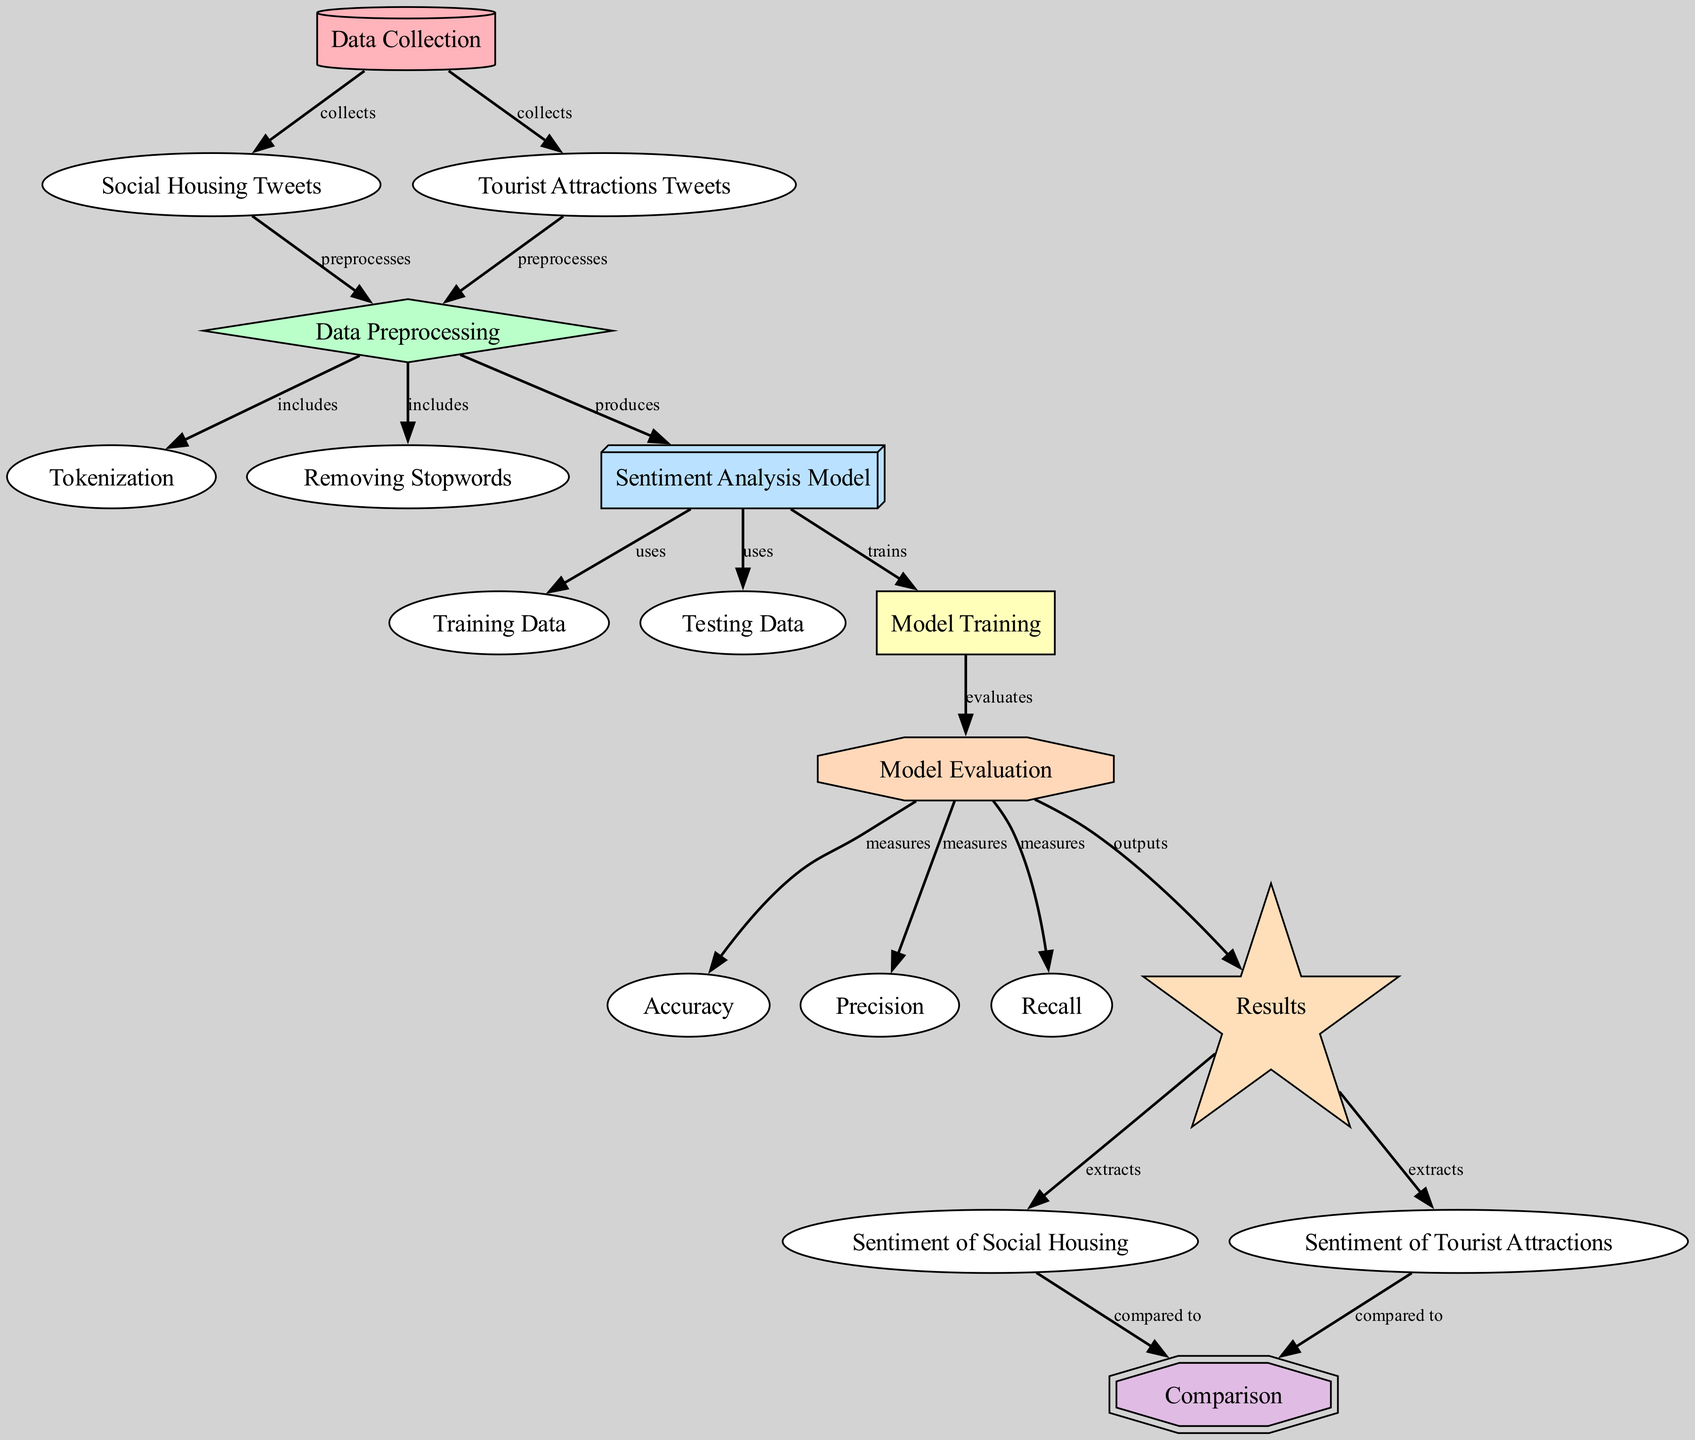What is the first step in the diagram? The diagram begins with the "Data Collection" node, which is the starting point for the entire process.
Answer: Data Collection How many types of tweets are collected? The diagram shows two types of tweets being collected: "Social Housing Tweets" and "Tourist Attractions Tweets." Therefore, the number is two.
Answer: Two Which node directly processes both types of tweets? The "Preprocessing" node directly processes both "Social Housing Tweets" and "Tourist Attractions Tweets," as indicated by the arrows leading to it from both nodes.
Answer: Preprocessing What is compared in the diagram? The diagram contains a "Comparison" node that compares the sentiments from "Sentiment of Social Housing" and "Sentiment of Tourist Attractions."
Answer: Sentiments List three metrics used in model evaluation. The diagram indicates that "Accuracy," "Precision," and "Recall" are measured as part of the model evaluation step.
Answer: Accuracy, Precision, Recall What does the "Sentiment Analysis Model" use for training? The "Sentiment Analysis Model" uses the "Training Data" node for training, as represented by the arrow pointing from "Training Data" to "Sentiment Analysis Model."
Answer: Training Data What kind of outputs does the "Model Evaluation" generate? The "Model Evaluation" node directly outputs the "Results," indicating that it produces these results after evaluating the model.
Answer: Results Which node is responsible for sentiment extraction? The "Results" node extracts sentiments for both social housing and tourist attractions, as shown by the arrows leading to "Sentiment of Social Housing" and "Sentiment of Tourist Attractions."
Answer: Results How many nodes are involved in the data preprocessing phase? There are three nodes involved in preprocessing: "Tokenization," "Removing Stopwords," and "Sentiment Analysis Model," all stemming from the "Preprocessing" node.
Answer: Three 